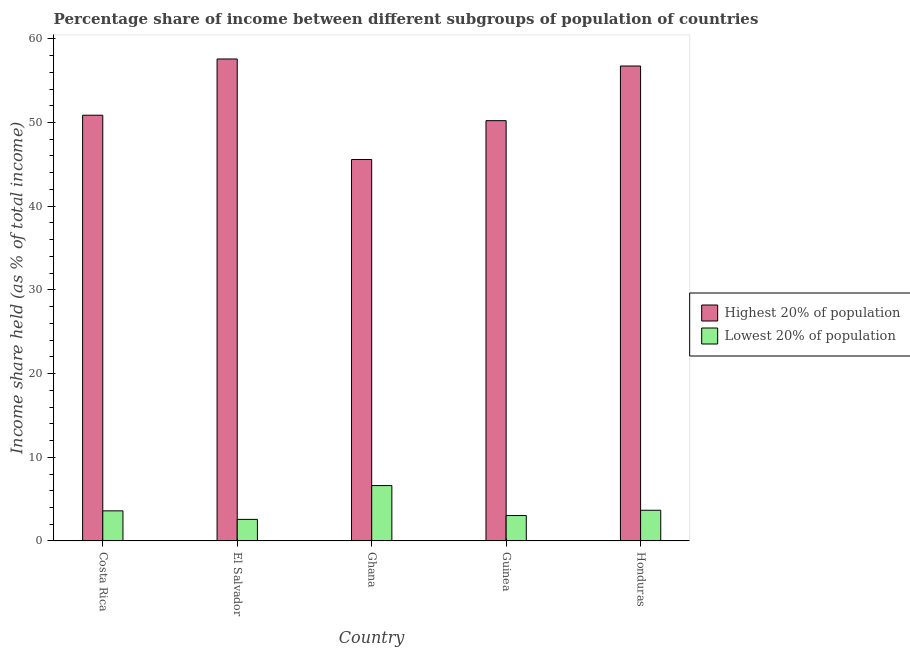How many groups of bars are there?
Ensure brevity in your answer.  5. In how many cases, is the number of bars for a given country not equal to the number of legend labels?
Provide a short and direct response. 0. What is the income share held by highest 20% of the population in El Salvador?
Provide a short and direct response. 57.59. Across all countries, what is the maximum income share held by lowest 20% of the population?
Keep it short and to the point. 6.62. Across all countries, what is the minimum income share held by highest 20% of the population?
Keep it short and to the point. 45.58. In which country was the income share held by highest 20% of the population maximum?
Your response must be concise. El Salvador. What is the total income share held by highest 20% of the population in the graph?
Keep it short and to the point. 261.01. What is the difference between the income share held by lowest 20% of the population in Ghana and that in Guinea?
Your answer should be compact. 3.58. What is the difference between the income share held by highest 20% of the population in Honduras and the income share held by lowest 20% of the population in Guinea?
Offer a terse response. 53.71. What is the average income share held by lowest 20% of the population per country?
Keep it short and to the point. 3.9. What is the difference between the income share held by lowest 20% of the population and income share held by highest 20% of the population in Guinea?
Keep it short and to the point. -47.18. In how many countries, is the income share held by lowest 20% of the population greater than 24 %?
Make the answer very short. 0. What is the ratio of the income share held by lowest 20% of the population in Ghana to that in Guinea?
Ensure brevity in your answer.  2.18. Is the income share held by highest 20% of the population in Guinea less than that in Honduras?
Offer a terse response. Yes. What is the difference between the highest and the second highest income share held by highest 20% of the population?
Offer a terse response. 0.84. What is the difference between the highest and the lowest income share held by lowest 20% of the population?
Keep it short and to the point. 4.04. In how many countries, is the income share held by highest 20% of the population greater than the average income share held by highest 20% of the population taken over all countries?
Provide a short and direct response. 2. What does the 2nd bar from the left in Guinea represents?
Provide a succinct answer. Lowest 20% of population. What does the 1st bar from the right in Honduras represents?
Provide a succinct answer. Lowest 20% of population. Does the graph contain grids?
Your answer should be compact. No. How are the legend labels stacked?
Provide a succinct answer. Vertical. What is the title of the graph?
Your response must be concise. Percentage share of income between different subgroups of population of countries. What is the label or title of the X-axis?
Make the answer very short. Country. What is the label or title of the Y-axis?
Your answer should be very brief. Income share held (as % of total income). What is the Income share held (as % of total income) in Highest 20% of population in Costa Rica?
Provide a succinct answer. 50.87. What is the Income share held (as % of total income) in Highest 20% of population in El Salvador?
Your answer should be compact. 57.59. What is the Income share held (as % of total income) of Lowest 20% of population in El Salvador?
Your answer should be very brief. 2.58. What is the Income share held (as % of total income) of Highest 20% of population in Ghana?
Keep it short and to the point. 45.58. What is the Income share held (as % of total income) of Lowest 20% of population in Ghana?
Offer a very short reply. 6.62. What is the Income share held (as % of total income) in Highest 20% of population in Guinea?
Your answer should be compact. 50.22. What is the Income share held (as % of total income) of Lowest 20% of population in Guinea?
Provide a short and direct response. 3.04. What is the Income share held (as % of total income) in Highest 20% of population in Honduras?
Keep it short and to the point. 56.75. What is the Income share held (as % of total income) in Lowest 20% of population in Honduras?
Provide a succinct answer. 3.67. Across all countries, what is the maximum Income share held (as % of total income) of Highest 20% of population?
Provide a succinct answer. 57.59. Across all countries, what is the maximum Income share held (as % of total income) of Lowest 20% of population?
Offer a very short reply. 6.62. Across all countries, what is the minimum Income share held (as % of total income) of Highest 20% of population?
Offer a very short reply. 45.58. Across all countries, what is the minimum Income share held (as % of total income) in Lowest 20% of population?
Keep it short and to the point. 2.58. What is the total Income share held (as % of total income) in Highest 20% of population in the graph?
Provide a succinct answer. 261.01. What is the total Income share held (as % of total income) in Lowest 20% of population in the graph?
Your answer should be compact. 19.51. What is the difference between the Income share held (as % of total income) in Highest 20% of population in Costa Rica and that in El Salvador?
Your response must be concise. -6.72. What is the difference between the Income share held (as % of total income) of Highest 20% of population in Costa Rica and that in Ghana?
Make the answer very short. 5.29. What is the difference between the Income share held (as % of total income) in Lowest 20% of population in Costa Rica and that in Ghana?
Your answer should be compact. -3.02. What is the difference between the Income share held (as % of total income) of Highest 20% of population in Costa Rica and that in Guinea?
Offer a very short reply. 0.65. What is the difference between the Income share held (as % of total income) in Lowest 20% of population in Costa Rica and that in Guinea?
Provide a short and direct response. 0.56. What is the difference between the Income share held (as % of total income) in Highest 20% of population in Costa Rica and that in Honduras?
Your response must be concise. -5.88. What is the difference between the Income share held (as % of total income) of Lowest 20% of population in Costa Rica and that in Honduras?
Make the answer very short. -0.07. What is the difference between the Income share held (as % of total income) in Highest 20% of population in El Salvador and that in Ghana?
Your answer should be very brief. 12.01. What is the difference between the Income share held (as % of total income) in Lowest 20% of population in El Salvador and that in Ghana?
Make the answer very short. -4.04. What is the difference between the Income share held (as % of total income) of Highest 20% of population in El Salvador and that in Guinea?
Give a very brief answer. 7.37. What is the difference between the Income share held (as % of total income) in Lowest 20% of population in El Salvador and that in Guinea?
Provide a short and direct response. -0.46. What is the difference between the Income share held (as % of total income) in Highest 20% of population in El Salvador and that in Honduras?
Provide a short and direct response. 0.84. What is the difference between the Income share held (as % of total income) in Lowest 20% of population in El Salvador and that in Honduras?
Provide a succinct answer. -1.09. What is the difference between the Income share held (as % of total income) in Highest 20% of population in Ghana and that in Guinea?
Your response must be concise. -4.64. What is the difference between the Income share held (as % of total income) of Lowest 20% of population in Ghana and that in Guinea?
Ensure brevity in your answer.  3.58. What is the difference between the Income share held (as % of total income) of Highest 20% of population in Ghana and that in Honduras?
Give a very brief answer. -11.17. What is the difference between the Income share held (as % of total income) in Lowest 20% of population in Ghana and that in Honduras?
Your response must be concise. 2.95. What is the difference between the Income share held (as % of total income) in Highest 20% of population in Guinea and that in Honduras?
Your answer should be very brief. -6.53. What is the difference between the Income share held (as % of total income) of Lowest 20% of population in Guinea and that in Honduras?
Provide a succinct answer. -0.63. What is the difference between the Income share held (as % of total income) in Highest 20% of population in Costa Rica and the Income share held (as % of total income) in Lowest 20% of population in El Salvador?
Offer a terse response. 48.29. What is the difference between the Income share held (as % of total income) of Highest 20% of population in Costa Rica and the Income share held (as % of total income) of Lowest 20% of population in Ghana?
Offer a terse response. 44.25. What is the difference between the Income share held (as % of total income) of Highest 20% of population in Costa Rica and the Income share held (as % of total income) of Lowest 20% of population in Guinea?
Your response must be concise. 47.83. What is the difference between the Income share held (as % of total income) of Highest 20% of population in Costa Rica and the Income share held (as % of total income) of Lowest 20% of population in Honduras?
Offer a terse response. 47.2. What is the difference between the Income share held (as % of total income) in Highest 20% of population in El Salvador and the Income share held (as % of total income) in Lowest 20% of population in Ghana?
Offer a terse response. 50.97. What is the difference between the Income share held (as % of total income) of Highest 20% of population in El Salvador and the Income share held (as % of total income) of Lowest 20% of population in Guinea?
Offer a very short reply. 54.55. What is the difference between the Income share held (as % of total income) of Highest 20% of population in El Salvador and the Income share held (as % of total income) of Lowest 20% of population in Honduras?
Give a very brief answer. 53.92. What is the difference between the Income share held (as % of total income) of Highest 20% of population in Ghana and the Income share held (as % of total income) of Lowest 20% of population in Guinea?
Make the answer very short. 42.54. What is the difference between the Income share held (as % of total income) in Highest 20% of population in Ghana and the Income share held (as % of total income) in Lowest 20% of population in Honduras?
Your answer should be very brief. 41.91. What is the difference between the Income share held (as % of total income) of Highest 20% of population in Guinea and the Income share held (as % of total income) of Lowest 20% of population in Honduras?
Provide a short and direct response. 46.55. What is the average Income share held (as % of total income) in Highest 20% of population per country?
Keep it short and to the point. 52.2. What is the average Income share held (as % of total income) of Lowest 20% of population per country?
Provide a succinct answer. 3.9. What is the difference between the Income share held (as % of total income) of Highest 20% of population and Income share held (as % of total income) of Lowest 20% of population in Costa Rica?
Give a very brief answer. 47.27. What is the difference between the Income share held (as % of total income) in Highest 20% of population and Income share held (as % of total income) in Lowest 20% of population in El Salvador?
Provide a succinct answer. 55.01. What is the difference between the Income share held (as % of total income) of Highest 20% of population and Income share held (as % of total income) of Lowest 20% of population in Ghana?
Make the answer very short. 38.96. What is the difference between the Income share held (as % of total income) of Highest 20% of population and Income share held (as % of total income) of Lowest 20% of population in Guinea?
Offer a very short reply. 47.18. What is the difference between the Income share held (as % of total income) of Highest 20% of population and Income share held (as % of total income) of Lowest 20% of population in Honduras?
Provide a short and direct response. 53.08. What is the ratio of the Income share held (as % of total income) of Highest 20% of population in Costa Rica to that in El Salvador?
Keep it short and to the point. 0.88. What is the ratio of the Income share held (as % of total income) in Lowest 20% of population in Costa Rica to that in El Salvador?
Make the answer very short. 1.4. What is the ratio of the Income share held (as % of total income) of Highest 20% of population in Costa Rica to that in Ghana?
Offer a terse response. 1.12. What is the ratio of the Income share held (as % of total income) in Lowest 20% of population in Costa Rica to that in Ghana?
Ensure brevity in your answer.  0.54. What is the ratio of the Income share held (as % of total income) of Highest 20% of population in Costa Rica to that in Guinea?
Ensure brevity in your answer.  1.01. What is the ratio of the Income share held (as % of total income) in Lowest 20% of population in Costa Rica to that in Guinea?
Offer a very short reply. 1.18. What is the ratio of the Income share held (as % of total income) of Highest 20% of population in Costa Rica to that in Honduras?
Ensure brevity in your answer.  0.9. What is the ratio of the Income share held (as % of total income) in Lowest 20% of population in Costa Rica to that in Honduras?
Make the answer very short. 0.98. What is the ratio of the Income share held (as % of total income) in Highest 20% of population in El Salvador to that in Ghana?
Ensure brevity in your answer.  1.26. What is the ratio of the Income share held (as % of total income) in Lowest 20% of population in El Salvador to that in Ghana?
Ensure brevity in your answer.  0.39. What is the ratio of the Income share held (as % of total income) in Highest 20% of population in El Salvador to that in Guinea?
Ensure brevity in your answer.  1.15. What is the ratio of the Income share held (as % of total income) in Lowest 20% of population in El Salvador to that in Guinea?
Provide a short and direct response. 0.85. What is the ratio of the Income share held (as % of total income) of Highest 20% of population in El Salvador to that in Honduras?
Give a very brief answer. 1.01. What is the ratio of the Income share held (as % of total income) of Lowest 20% of population in El Salvador to that in Honduras?
Your answer should be very brief. 0.7. What is the ratio of the Income share held (as % of total income) of Highest 20% of population in Ghana to that in Guinea?
Offer a terse response. 0.91. What is the ratio of the Income share held (as % of total income) of Lowest 20% of population in Ghana to that in Guinea?
Offer a very short reply. 2.18. What is the ratio of the Income share held (as % of total income) of Highest 20% of population in Ghana to that in Honduras?
Your response must be concise. 0.8. What is the ratio of the Income share held (as % of total income) in Lowest 20% of population in Ghana to that in Honduras?
Your answer should be very brief. 1.8. What is the ratio of the Income share held (as % of total income) of Highest 20% of population in Guinea to that in Honduras?
Your response must be concise. 0.88. What is the ratio of the Income share held (as % of total income) of Lowest 20% of population in Guinea to that in Honduras?
Your response must be concise. 0.83. What is the difference between the highest and the second highest Income share held (as % of total income) in Highest 20% of population?
Ensure brevity in your answer.  0.84. What is the difference between the highest and the second highest Income share held (as % of total income) in Lowest 20% of population?
Provide a succinct answer. 2.95. What is the difference between the highest and the lowest Income share held (as % of total income) of Highest 20% of population?
Your answer should be very brief. 12.01. What is the difference between the highest and the lowest Income share held (as % of total income) of Lowest 20% of population?
Your answer should be very brief. 4.04. 